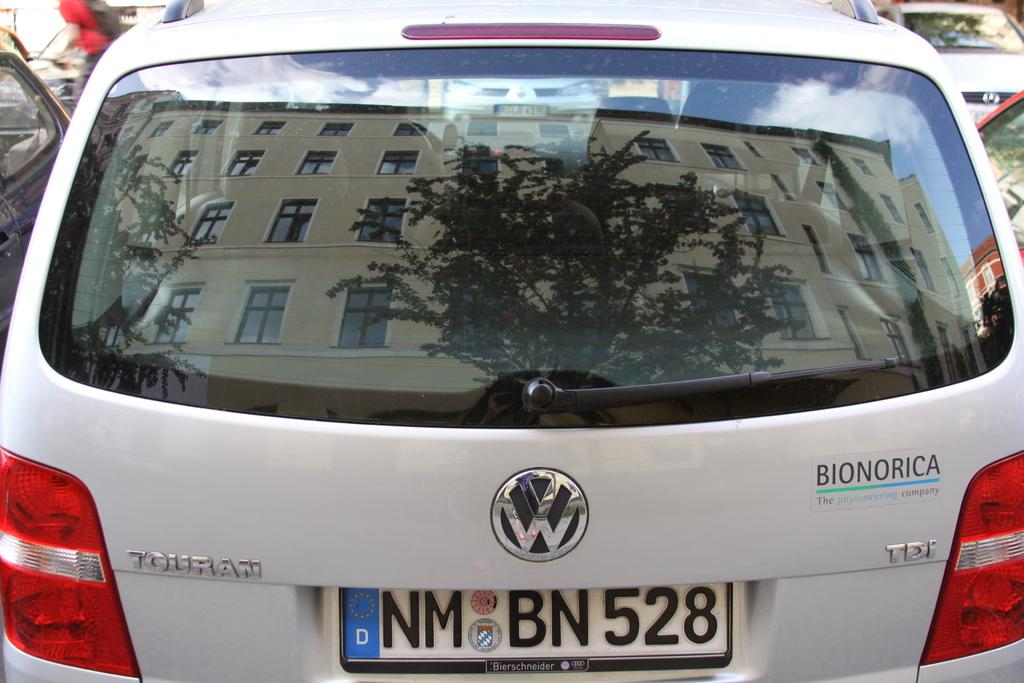What is the main subject of the image? There is a car in the image. From which angle is the car viewed? The car is viewed from the back. What is the purpose of the glass window in the image? The glass window allows for visibility of the surroundings. What can be seen through the glass window? Buildings and trees are visible through the glass window. Where is the crown placed in the image? There is no crown present in the image. What type of pin can be seen holding the curtains in the image? There are no curtains or pins present in the image. 